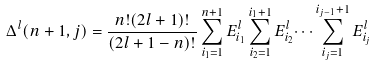Convert formula to latex. <formula><loc_0><loc_0><loc_500><loc_500>\Delta ^ { l } ( n + 1 , j ) = \frac { n ! ( 2 l + 1 ) ! } { ( 2 l + 1 - n ) ! } \sum _ { i _ { 1 } = 1 } ^ { n + 1 } E ^ { l } _ { i _ { 1 } } \sum _ { i _ { 2 } = 1 } ^ { i _ { 1 } + 1 } E ^ { l } _ { i _ { 2 } } \dots \sum _ { i _ { j } = 1 } ^ { i _ { j - 1 } + 1 } E ^ { l } _ { i _ { j } }</formula> 